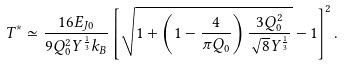Convert formula to latex. <formula><loc_0><loc_0><loc_500><loc_500>T ^ { * } \simeq \frac { 1 6 E _ { J 0 } } { 9 Q _ { 0 } ^ { 2 } Y ^ { \frac { 1 } { 3 } } k _ { B } } \left [ \sqrt { 1 + \left ( 1 - \frac { 4 } { \pi Q _ { 0 } } \right ) \frac { 3 Q _ { 0 } ^ { 2 } } { \sqrt { 8 } Y ^ { \frac { 1 } { 3 } } } } - 1 \right ] ^ { 2 } .</formula> 